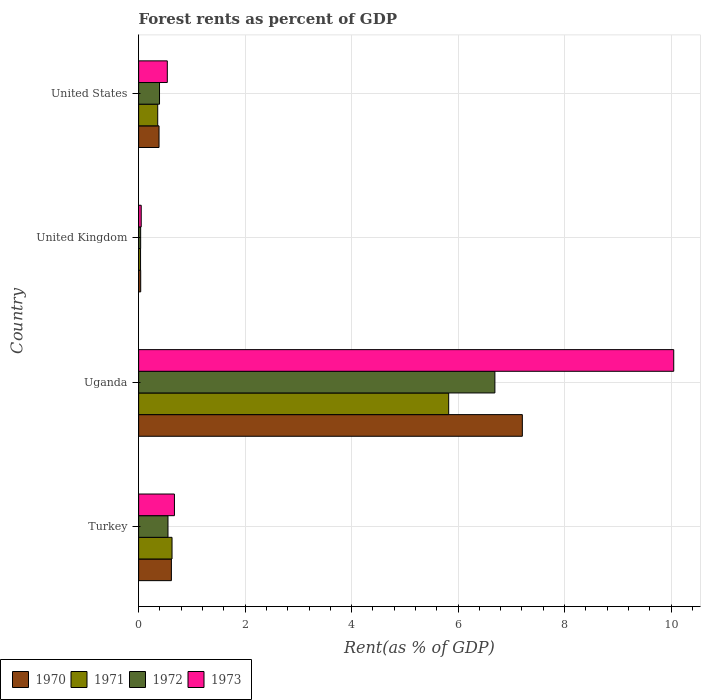Are the number of bars per tick equal to the number of legend labels?
Give a very brief answer. Yes. How many bars are there on the 3rd tick from the top?
Offer a very short reply. 4. What is the label of the 3rd group of bars from the top?
Ensure brevity in your answer.  Uganda. In how many cases, is the number of bars for a given country not equal to the number of legend labels?
Your answer should be compact. 0. What is the forest rent in 1970 in United Kingdom?
Ensure brevity in your answer.  0.04. Across all countries, what is the maximum forest rent in 1972?
Provide a short and direct response. 6.69. Across all countries, what is the minimum forest rent in 1970?
Keep it short and to the point. 0.04. In which country was the forest rent in 1971 maximum?
Ensure brevity in your answer.  Uganda. In which country was the forest rent in 1970 minimum?
Your answer should be very brief. United Kingdom. What is the total forest rent in 1973 in the graph?
Offer a terse response. 11.31. What is the difference between the forest rent in 1973 in Uganda and that in United Kingdom?
Ensure brevity in your answer.  10. What is the difference between the forest rent in 1972 in Uganda and the forest rent in 1973 in United Kingdom?
Your answer should be very brief. 6.64. What is the average forest rent in 1973 per country?
Your answer should be very brief. 2.83. What is the difference between the forest rent in 1973 and forest rent in 1970 in Uganda?
Ensure brevity in your answer.  2.84. In how many countries, is the forest rent in 1970 greater than 1.2000000000000002 %?
Give a very brief answer. 1. What is the ratio of the forest rent in 1971 in Turkey to that in United States?
Your answer should be compact. 1.75. Is the forest rent in 1973 in United Kingdom less than that in United States?
Make the answer very short. Yes. Is the difference between the forest rent in 1973 in Uganda and United States greater than the difference between the forest rent in 1970 in Uganda and United States?
Ensure brevity in your answer.  Yes. What is the difference between the highest and the second highest forest rent in 1973?
Your answer should be compact. 9.38. What is the difference between the highest and the lowest forest rent in 1970?
Make the answer very short. 7.17. In how many countries, is the forest rent in 1970 greater than the average forest rent in 1970 taken over all countries?
Your answer should be compact. 1. Is the sum of the forest rent in 1970 in Turkey and Uganda greater than the maximum forest rent in 1973 across all countries?
Your answer should be very brief. No. What does the 1st bar from the top in United States represents?
Your answer should be compact. 1973. What does the 1st bar from the bottom in United States represents?
Your answer should be compact. 1970. Is it the case that in every country, the sum of the forest rent in 1973 and forest rent in 1971 is greater than the forest rent in 1970?
Offer a very short reply. Yes. What is the difference between two consecutive major ticks on the X-axis?
Your answer should be compact. 2. Does the graph contain grids?
Provide a succinct answer. Yes. Where does the legend appear in the graph?
Give a very brief answer. Bottom left. How are the legend labels stacked?
Your answer should be compact. Horizontal. What is the title of the graph?
Ensure brevity in your answer.  Forest rents as percent of GDP. What is the label or title of the X-axis?
Provide a short and direct response. Rent(as % of GDP). What is the Rent(as % of GDP) of 1970 in Turkey?
Provide a succinct answer. 0.62. What is the Rent(as % of GDP) of 1971 in Turkey?
Give a very brief answer. 0.63. What is the Rent(as % of GDP) of 1972 in Turkey?
Offer a terse response. 0.55. What is the Rent(as % of GDP) in 1973 in Turkey?
Make the answer very short. 0.67. What is the Rent(as % of GDP) in 1970 in Uganda?
Give a very brief answer. 7.21. What is the Rent(as % of GDP) in 1971 in Uganda?
Give a very brief answer. 5.82. What is the Rent(as % of GDP) in 1972 in Uganda?
Offer a very short reply. 6.69. What is the Rent(as % of GDP) of 1973 in Uganda?
Keep it short and to the point. 10.05. What is the Rent(as % of GDP) in 1970 in United Kingdom?
Your answer should be very brief. 0.04. What is the Rent(as % of GDP) in 1971 in United Kingdom?
Your answer should be compact. 0.04. What is the Rent(as % of GDP) of 1972 in United Kingdom?
Provide a short and direct response. 0.04. What is the Rent(as % of GDP) of 1973 in United Kingdom?
Your answer should be very brief. 0.05. What is the Rent(as % of GDP) of 1970 in United States?
Keep it short and to the point. 0.38. What is the Rent(as % of GDP) in 1971 in United States?
Provide a short and direct response. 0.36. What is the Rent(as % of GDP) of 1972 in United States?
Provide a succinct answer. 0.39. What is the Rent(as % of GDP) in 1973 in United States?
Give a very brief answer. 0.54. Across all countries, what is the maximum Rent(as % of GDP) in 1970?
Offer a terse response. 7.21. Across all countries, what is the maximum Rent(as % of GDP) of 1971?
Provide a short and direct response. 5.82. Across all countries, what is the maximum Rent(as % of GDP) in 1972?
Make the answer very short. 6.69. Across all countries, what is the maximum Rent(as % of GDP) in 1973?
Your response must be concise. 10.05. Across all countries, what is the minimum Rent(as % of GDP) of 1970?
Give a very brief answer. 0.04. Across all countries, what is the minimum Rent(as % of GDP) of 1971?
Give a very brief answer. 0.04. Across all countries, what is the minimum Rent(as % of GDP) in 1972?
Your response must be concise. 0.04. Across all countries, what is the minimum Rent(as % of GDP) of 1973?
Give a very brief answer. 0.05. What is the total Rent(as % of GDP) in 1970 in the graph?
Offer a terse response. 8.24. What is the total Rent(as % of GDP) of 1971 in the graph?
Your response must be concise. 6.85. What is the total Rent(as % of GDP) in 1972 in the graph?
Make the answer very short. 7.67. What is the total Rent(as % of GDP) in 1973 in the graph?
Your answer should be compact. 11.31. What is the difference between the Rent(as % of GDP) in 1970 in Turkey and that in Uganda?
Make the answer very short. -6.59. What is the difference between the Rent(as % of GDP) of 1971 in Turkey and that in Uganda?
Keep it short and to the point. -5.2. What is the difference between the Rent(as % of GDP) in 1972 in Turkey and that in Uganda?
Your answer should be very brief. -6.14. What is the difference between the Rent(as % of GDP) in 1973 in Turkey and that in Uganda?
Your answer should be very brief. -9.38. What is the difference between the Rent(as % of GDP) in 1970 in Turkey and that in United Kingdom?
Make the answer very short. 0.58. What is the difference between the Rent(as % of GDP) in 1971 in Turkey and that in United Kingdom?
Your response must be concise. 0.59. What is the difference between the Rent(as % of GDP) of 1972 in Turkey and that in United Kingdom?
Ensure brevity in your answer.  0.51. What is the difference between the Rent(as % of GDP) in 1973 in Turkey and that in United Kingdom?
Keep it short and to the point. 0.62. What is the difference between the Rent(as % of GDP) of 1970 in Turkey and that in United States?
Provide a short and direct response. 0.23. What is the difference between the Rent(as % of GDP) of 1971 in Turkey and that in United States?
Give a very brief answer. 0.27. What is the difference between the Rent(as % of GDP) in 1972 in Turkey and that in United States?
Offer a very short reply. 0.16. What is the difference between the Rent(as % of GDP) in 1973 in Turkey and that in United States?
Make the answer very short. 0.13. What is the difference between the Rent(as % of GDP) in 1970 in Uganda and that in United Kingdom?
Offer a terse response. 7.17. What is the difference between the Rent(as % of GDP) of 1971 in Uganda and that in United Kingdom?
Provide a short and direct response. 5.79. What is the difference between the Rent(as % of GDP) of 1972 in Uganda and that in United Kingdom?
Give a very brief answer. 6.65. What is the difference between the Rent(as % of GDP) in 1973 in Uganda and that in United Kingdom?
Make the answer very short. 10. What is the difference between the Rent(as % of GDP) of 1970 in Uganda and that in United States?
Keep it short and to the point. 6.82. What is the difference between the Rent(as % of GDP) in 1971 in Uganda and that in United States?
Your answer should be compact. 5.47. What is the difference between the Rent(as % of GDP) of 1972 in Uganda and that in United States?
Offer a very short reply. 6.3. What is the difference between the Rent(as % of GDP) in 1973 in Uganda and that in United States?
Ensure brevity in your answer.  9.51. What is the difference between the Rent(as % of GDP) in 1970 in United Kingdom and that in United States?
Make the answer very short. -0.34. What is the difference between the Rent(as % of GDP) in 1971 in United Kingdom and that in United States?
Ensure brevity in your answer.  -0.32. What is the difference between the Rent(as % of GDP) of 1972 in United Kingdom and that in United States?
Your answer should be compact. -0.35. What is the difference between the Rent(as % of GDP) in 1973 in United Kingdom and that in United States?
Provide a succinct answer. -0.49. What is the difference between the Rent(as % of GDP) in 1970 in Turkey and the Rent(as % of GDP) in 1971 in Uganda?
Ensure brevity in your answer.  -5.21. What is the difference between the Rent(as % of GDP) of 1970 in Turkey and the Rent(as % of GDP) of 1972 in Uganda?
Keep it short and to the point. -6.08. What is the difference between the Rent(as % of GDP) of 1970 in Turkey and the Rent(as % of GDP) of 1973 in Uganda?
Keep it short and to the point. -9.44. What is the difference between the Rent(as % of GDP) in 1971 in Turkey and the Rent(as % of GDP) in 1972 in Uganda?
Provide a succinct answer. -6.06. What is the difference between the Rent(as % of GDP) of 1971 in Turkey and the Rent(as % of GDP) of 1973 in Uganda?
Your answer should be compact. -9.42. What is the difference between the Rent(as % of GDP) in 1972 in Turkey and the Rent(as % of GDP) in 1973 in Uganda?
Your answer should be compact. -9.5. What is the difference between the Rent(as % of GDP) of 1970 in Turkey and the Rent(as % of GDP) of 1971 in United Kingdom?
Provide a short and direct response. 0.58. What is the difference between the Rent(as % of GDP) in 1970 in Turkey and the Rent(as % of GDP) in 1972 in United Kingdom?
Your response must be concise. 0.58. What is the difference between the Rent(as % of GDP) in 1970 in Turkey and the Rent(as % of GDP) in 1973 in United Kingdom?
Give a very brief answer. 0.57. What is the difference between the Rent(as % of GDP) in 1971 in Turkey and the Rent(as % of GDP) in 1972 in United Kingdom?
Your answer should be compact. 0.59. What is the difference between the Rent(as % of GDP) of 1971 in Turkey and the Rent(as % of GDP) of 1973 in United Kingdom?
Provide a succinct answer. 0.58. What is the difference between the Rent(as % of GDP) of 1972 in Turkey and the Rent(as % of GDP) of 1973 in United Kingdom?
Your response must be concise. 0.5. What is the difference between the Rent(as % of GDP) of 1970 in Turkey and the Rent(as % of GDP) of 1971 in United States?
Offer a terse response. 0.26. What is the difference between the Rent(as % of GDP) in 1970 in Turkey and the Rent(as % of GDP) in 1972 in United States?
Provide a short and direct response. 0.22. What is the difference between the Rent(as % of GDP) in 1970 in Turkey and the Rent(as % of GDP) in 1973 in United States?
Provide a succinct answer. 0.08. What is the difference between the Rent(as % of GDP) of 1971 in Turkey and the Rent(as % of GDP) of 1972 in United States?
Provide a succinct answer. 0.23. What is the difference between the Rent(as % of GDP) in 1971 in Turkey and the Rent(as % of GDP) in 1973 in United States?
Provide a short and direct response. 0.09. What is the difference between the Rent(as % of GDP) of 1972 in Turkey and the Rent(as % of GDP) of 1973 in United States?
Your response must be concise. 0.01. What is the difference between the Rent(as % of GDP) in 1970 in Uganda and the Rent(as % of GDP) in 1971 in United Kingdom?
Ensure brevity in your answer.  7.17. What is the difference between the Rent(as % of GDP) in 1970 in Uganda and the Rent(as % of GDP) in 1972 in United Kingdom?
Keep it short and to the point. 7.17. What is the difference between the Rent(as % of GDP) of 1970 in Uganda and the Rent(as % of GDP) of 1973 in United Kingdom?
Offer a terse response. 7.16. What is the difference between the Rent(as % of GDP) in 1971 in Uganda and the Rent(as % of GDP) in 1972 in United Kingdom?
Ensure brevity in your answer.  5.79. What is the difference between the Rent(as % of GDP) in 1971 in Uganda and the Rent(as % of GDP) in 1973 in United Kingdom?
Give a very brief answer. 5.78. What is the difference between the Rent(as % of GDP) of 1972 in Uganda and the Rent(as % of GDP) of 1973 in United Kingdom?
Offer a very short reply. 6.64. What is the difference between the Rent(as % of GDP) in 1970 in Uganda and the Rent(as % of GDP) in 1971 in United States?
Your answer should be very brief. 6.85. What is the difference between the Rent(as % of GDP) in 1970 in Uganda and the Rent(as % of GDP) in 1972 in United States?
Ensure brevity in your answer.  6.81. What is the difference between the Rent(as % of GDP) of 1970 in Uganda and the Rent(as % of GDP) of 1973 in United States?
Give a very brief answer. 6.67. What is the difference between the Rent(as % of GDP) of 1971 in Uganda and the Rent(as % of GDP) of 1972 in United States?
Offer a terse response. 5.43. What is the difference between the Rent(as % of GDP) of 1971 in Uganda and the Rent(as % of GDP) of 1973 in United States?
Make the answer very short. 5.29. What is the difference between the Rent(as % of GDP) of 1972 in Uganda and the Rent(as % of GDP) of 1973 in United States?
Your answer should be compact. 6.15. What is the difference between the Rent(as % of GDP) of 1970 in United Kingdom and the Rent(as % of GDP) of 1971 in United States?
Ensure brevity in your answer.  -0.32. What is the difference between the Rent(as % of GDP) of 1970 in United Kingdom and the Rent(as % of GDP) of 1972 in United States?
Provide a short and direct response. -0.35. What is the difference between the Rent(as % of GDP) in 1970 in United Kingdom and the Rent(as % of GDP) in 1973 in United States?
Your answer should be very brief. -0.5. What is the difference between the Rent(as % of GDP) of 1971 in United Kingdom and the Rent(as % of GDP) of 1972 in United States?
Your answer should be compact. -0.36. What is the difference between the Rent(as % of GDP) of 1971 in United Kingdom and the Rent(as % of GDP) of 1973 in United States?
Your answer should be compact. -0.5. What is the difference between the Rent(as % of GDP) in 1972 in United Kingdom and the Rent(as % of GDP) in 1973 in United States?
Your answer should be very brief. -0.5. What is the average Rent(as % of GDP) of 1970 per country?
Offer a terse response. 2.06. What is the average Rent(as % of GDP) of 1971 per country?
Provide a short and direct response. 1.71. What is the average Rent(as % of GDP) in 1972 per country?
Provide a succinct answer. 1.92. What is the average Rent(as % of GDP) of 1973 per country?
Make the answer very short. 2.83. What is the difference between the Rent(as % of GDP) in 1970 and Rent(as % of GDP) in 1971 in Turkey?
Provide a short and direct response. -0.01. What is the difference between the Rent(as % of GDP) of 1970 and Rent(as % of GDP) of 1972 in Turkey?
Provide a succinct answer. 0.06. What is the difference between the Rent(as % of GDP) in 1970 and Rent(as % of GDP) in 1973 in Turkey?
Provide a succinct answer. -0.06. What is the difference between the Rent(as % of GDP) of 1971 and Rent(as % of GDP) of 1972 in Turkey?
Your response must be concise. 0.08. What is the difference between the Rent(as % of GDP) of 1971 and Rent(as % of GDP) of 1973 in Turkey?
Ensure brevity in your answer.  -0.05. What is the difference between the Rent(as % of GDP) in 1972 and Rent(as % of GDP) in 1973 in Turkey?
Provide a short and direct response. -0.12. What is the difference between the Rent(as % of GDP) of 1970 and Rent(as % of GDP) of 1971 in Uganda?
Provide a short and direct response. 1.38. What is the difference between the Rent(as % of GDP) in 1970 and Rent(as % of GDP) in 1972 in Uganda?
Offer a very short reply. 0.52. What is the difference between the Rent(as % of GDP) of 1970 and Rent(as % of GDP) of 1973 in Uganda?
Ensure brevity in your answer.  -2.84. What is the difference between the Rent(as % of GDP) in 1971 and Rent(as % of GDP) in 1972 in Uganda?
Keep it short and to the point. -0.87. What is the difference between the Rent(as % of GDP) of 1971 and Rent(as % of GDP) of 1973 in Uganda?
Make the answer very short. -4.23. What is the difference between the Rent(as % of GDP) in 1972 and Rent(as % of GDP) in 1973 in Uganda?
Provide a short and direct response. -3.36. What is the difference between the Rent(as % of GDP) in 1970 and Rent(as % of GDP) in 1971 in United Kingdom?
Make the answer very short. 0. What is the difference between the Rent(as % of GDP) in 1970 and Rent(as % of GDP) in 1972 in United Kingdom?
Keep it short and to the point. 0. What is the difference between the Rent(as % of GDP) in 1970 and Rent(as % of GDP) in 1973 in United Kingdom?
Your answer should be compact. -0.01. What is the difference between the Rent(as % of GDP) of 1971 and Rent(as % of GDP) of 1972 in United Kingdom?
Your answer should be very brief. -0. What is the difference between the Rent(as % of GDP) of 1971 and Rent(as % of GDP) of 1973 in United Kingdom?
Your answer should be compact. -0.01. What is the difference between the Rent(as % of GDP) in 1972 and Rent(as % of GDP) in 1973 in United Kingdom?
Ensure brevity in your answer.  -0.01. What is the difference between the Rent(as % of GDP) of 1970 and Rent(as % of GDP) of 1971 in United States?
Give a very brief answer. 0.02. What is the difference between the Rent(as % of GDP) of 1970 and Rent(as % of GDP) of 1972 in United States?
Provide a short and direct response. -0.01. What is the difference between the Rent(as % of GDP) of 1970 and Rent(as % of GDP) of 1973 in United States?
Your answer should be very brief. -0.16. What is the difference between the Rent(as % of GDP) in 1971 and Rent(as % of GDP) in 1972 in United States?
Offer a very short reply. -0.03. What is the difference between the Rent(as % of GDP) in 1971 and Rent(as % of GDP) in 1973 in United States?
Keep it short and to the point. -0.18. What is the difference between the Rent(as % of GDP) of 1972 and Rent(as % of GDP) of 1973 in United States?
Your answer should be very brief. -0.15. What is the ratio of the Rent(as % of GDP) of 1970 in Turkey to that in Uganda?
Give a very brief answer. 0.09. What is the ratio of the Rent(as % of GDP) in 1971 in Turkey to that in Uganda?
Offer a terse response. 0.11. What is the ratio of the Rent(as % of GDP) of 1972 in Turkey to that in Uganda?
Ensure brevity in your answer.  0.08. What is the ratio of the Rent(as % of GDP) in 1973 in Turkey to that in Uganda?
Your answer should be compact. 0.07. What is the ratio of the Rent(as % of GDP) in 1970 in Turkey to that in United Kingdom?
Make the answer very short. 15.78. What is the ratio of the Rent(as % of GDP) in 1971 in Turkey to that in United Kingdom?
Your answer should be compact. 17.29. What is the ratio of the Rent(as % of GDP) of 1972 in Turkey to that in United Kingdom?
Provide a succinct answer. 14.49. What is the ratio of the Rent(as % of GDP) in 1973 in Turkey to that in United Kingdom?
Offer a very short reply. 13.83. What is the ratio of the Rent(as % of GDP) of 1970 in Turkey to that in United States?
Offer a terse response. 1.61. What is the ratio of the Rent(as % of GDP) of 1971 in Turkey to that in United States?
Make the answer very short. 1.75. What is the ratio of the Rent(as % of GDP) of 1972 in Turkey to that in United States?
Keep it short and to the point. 1.41. What is the ratio of the Rent(as % of GDP) in 1973 in Turkey to that in United States?
Your answer should be very brief. 1.25. What is the ratio of the Rent(as % of GDP) of 1970 in Uganda to that in United Kingdom?
Make the answer very short. 184.81. What is the ratio of the Rent(as % of GDP) of 1971 in Uganda to that in United Kingdom?
Provide a succinct answer. 160.46. What is the ratio of the Rent(as % of GDP) in 1972 in Uganda to that in United Kingdom?
Keep it short and to the point. 175.86. What is the ratio of the Rent(as % of GDP) in 1973 in Uganda to that in United Kingdom?
Provide a short and direct response. 206.75. What is the ratio of the Rent(as % of GDP) of 1970 in Uganda to that in United States?
Offer a very short reply. 18.8. What is the ratio of the Rent(as % of GDP) of 1971 in Uganda to that in United States?
Provide a short and direct response. 16.24. What is the ratio of the Rent(as % of GDP) in 1972 in Uganda to that in United States?
Your answer should be very brief. 17.05. What is the ratio of the Rent(as % of GDP) in 1973 in Uganda to that in United States?
Offer a very short reply. 18.66. What is the ratio of the Rent(as % of GDP) of 1970 in United Kingdom to that in United States?
Offer a very short reply. 0.1. What is the ratio of the Rent(as % of GDP) of 1971 in United Kingdom to that in United States?
Make the answer very short. 0.1. What is the ratio of the Rent(as % of GDP) in 1972 in United Kingdom to that in United States?
Offer a terse response. 0.1. What is the ratio of the Rent(as % of GDP) in 1973 in United Kingdom to that in United States?
Offer a terse response. 0.09. What is the difference between the highest and the second highest Rent(as % of GDP) in 1970?
Your response must be concise. 6.59. What is the difference between the highest and the second highest Rent(as % of GDP) in 1971?
Keep it short and to the point. 5.2. What is the difference between the highest and the second highest Rent(as % of GDP) in 1972?
Give a very brief answer. 6.14. What is the difference between the highest and the second highest Rent(as % of GDP) in 1973?
Provide a succinct answer. 9.38. What is the difference between the highest and the lowest Rent(as % of GDP) in 1970?
Ensure brevity in your answer.  7.17. What is the difference between the highest and the lowest Rent(as % of GDP) in 1971?
Ensure brevity in your answer.  5.79. What is the difference between the highest and the lowest Rent(as % of GDP) of 1972?
Ensure brevity in your answer.  6.65. What is the difference between the highest and the lowest Rent(as % of GDP) of 1973?
Your response must be concise. 10. 